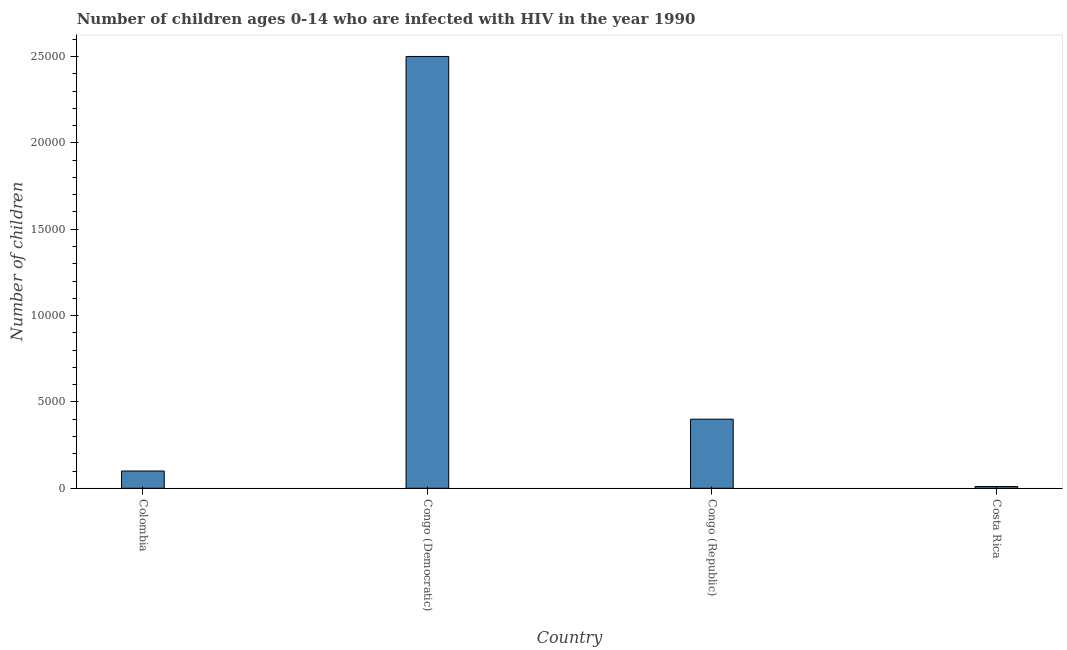Does the graph contain any zero values?
Provide a succinct answer. No. What is the title of the graph?
Make the answer very short. Number of children ages 0-14 who are infected with HIV in the year 1990. What is the label or title of the X-axis?
Offer a very short reply. Country. What is the label or title of the Y-axis?
Offer a very short reply. Number of children. What is the number of children living with hiv in Congo (Republic)?
Provide a succinct answer. 4000. Across all countries, what is the maximum number of children living with hiv?
Give a very brief answer. 2.50e+04. Across all countries, what is the minimum number of children living with hiv?
Keep it short and to the point. 100. In which country was the number of children living with hiv maximum?
Offer a terse response. Congo (Democratic). What is the sum of the number of children living with hiv?
Offer a very short reply. 3.01e+04. What is the difference between the number of children living with hiv in Congo (Republic) and Costa Rica?
Your answer should be compact. 3900. What is the average number of children living with hiv per country?
Ensure brevity in your answer.  7525. What is the median number of children living with hiv?
Your answer should be very brief. 2500. In how many countries, is the number of children living with hiv greater than 22000 ?
Your answer should be compact. 1. What is the ratio of the number of children living with hiv in Colombia to that in Costa Rica?
Keep it short and to the point. 10. What is the difference between the highest and the second highest number of children living with hiv?
Give a very brief answer. 2.10e+04. Is the sum of the number of children living with hiv in Congo (Republic) and Costa Rica greater than the maximum number of children living with hiv across all countries?
Ensure brevity in your answer.  No. What is the difference between the highest and the lowest number of children living with hiv?
Offer a very short reply. 2.49e+04. In how many countries, is the number of children living with hiv greater than the average number of children living with hiv taken over all countries?
Provide a succinct answer. 1. What is the difference between two consecutive major ticks on the Y-axis?
Make the answer very short. 5000. Are the values on the major ticks of Y-axis written in scientific E-notation?
Ensure brevity in your answer.  No. What is the Number of children of Congo (Democratic)?
Your answer should be very brief. 2.50e+04. What is the Number of children in Congo (Republic)?
Your response must be concise. 4000. What is the difference between the Number of children in Colombia and Congo (Democratic)?
Your answer should be compact. -2.40e+04. What is the difference between the Number of children in Colombia and Congo (Republic)?
Keep it short and to the point. -3000. What is the difference between the Number of children in Colombia and Costa Rica?
Provide a succinct answer. 900. What is the difference between the Number of children in Congo (Democratic) and Congo (Republic)?
Make the answer very short. 2.10e+04. What is the difference between the Number of children in Congo (Democratic) and Costa Rica?
Offer a terse response. 2.49e+04. What is the difference between the Number of children in Congo (Republic) and Costa Rica?
Give a very brief answer. 3900. What is the ratio of the Number of children in Congo (Democratic) to that in Congo (Republic)?
Offer a terse response. 6.25. What is the ratio of the Number of children in Congo (Democratic) to that in Costa Rica?
Offer a very short reply. 250. 